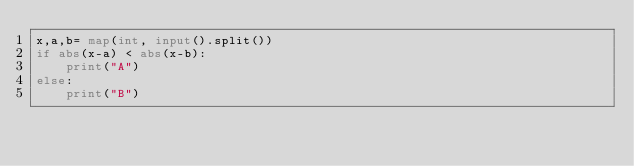Convert code to text. <code><loc_0><loc_0><loc_500><loc_500><_Python_>x,a,b= map(int, input().split())
if abs(x-a) < abs(x-b):
    print("A")
else:
    print("B")</code> 